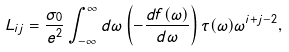<formula> <loc_0><loc_0><loc_500><loc_500>L _ { i j } = \frac { \sigma _ { 0 } } { e ^ { 2 } } \int _ { - \infty } ^ { \infty } d \omega \left ( - \frac { d f ( \omega ) } { d \omega } \right ) \tau ( \omega ) \omega ^ { i + j - 2 } ,</formula> 